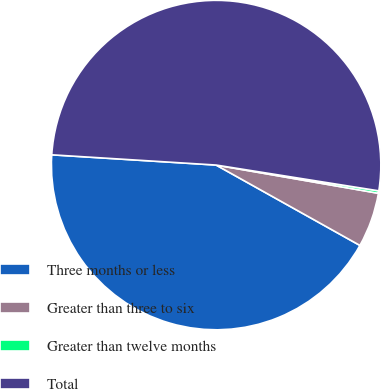<chart> <loc_0><loc_0><loc_500><loc_500><pie_chart><fcel>Three months or less<fcel>Greater than three to six<fcel>Greater than twelve months<fcel>Total<nl><fcel>42.88%<fcel>5.37%<fcel>0.24%<fcel>51.51%<nl></chart> 